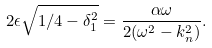<formula> <loc_0><loc_0><loc_500><loc_500>2 \epsilon \sqrt { 1 / 4 - \delta _ { 1 } ^ { 2 } } = \frac { \alpha \omega } { 2 ( \omega ^ { 2 } - k _ { n } ^ { 2 } ) } .</formula> 